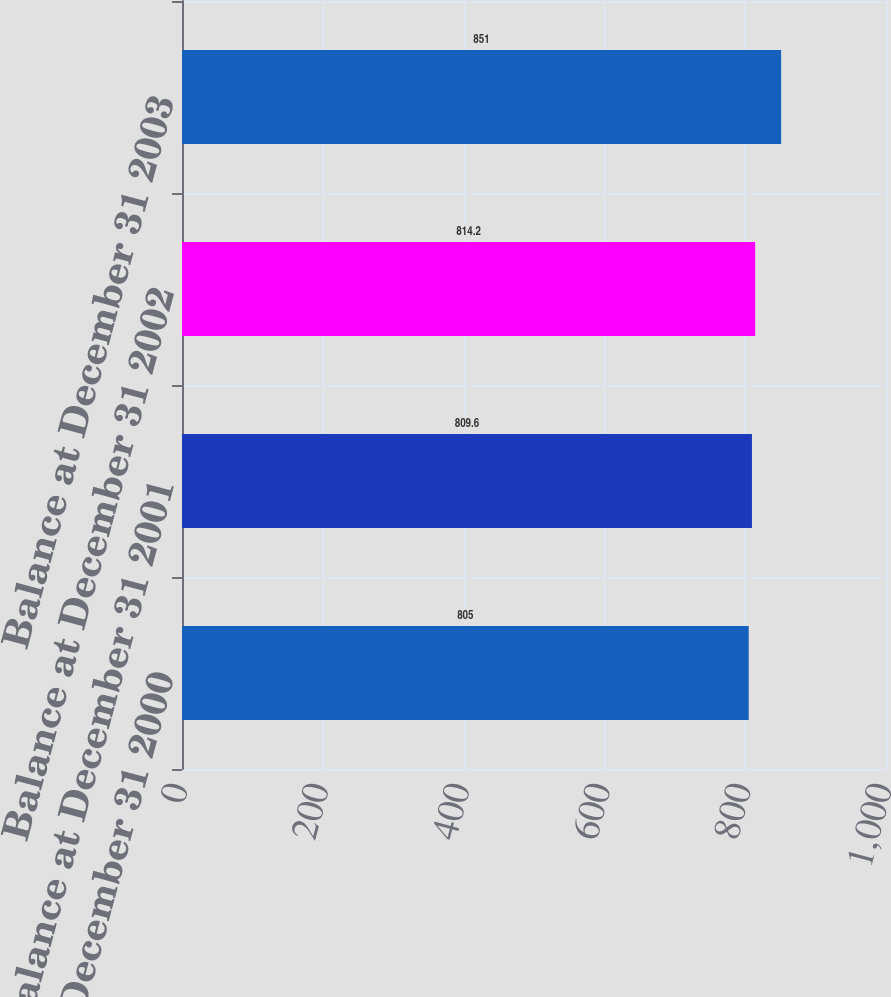Convert chart. <chart><loc_0><loc_0><loc_500><loc_500><bar_chart><fcel>Balance at December 31 2000<fcel>Balance at December 31 2001<fcel>Balance at December 31 2002<fcel>Balance at December 31 2003<nl><fcel>805<fcel>809.6<fcel>814.2<fcel>851<nl></chart> 